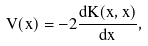<formula> <loc_0><loc_0><loc_500><loc_500>V ( x ) = - 2 \frac { d K ( x , x ) } { d x } ,</formula> 